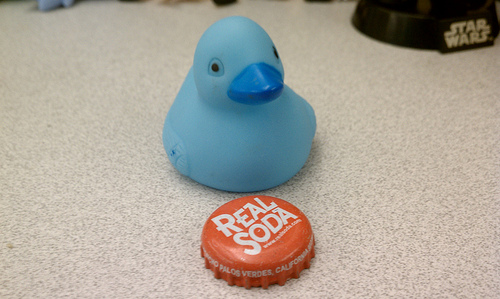<image>
Can you confirm if the label is on the bottle cap? Yes. Looking at the image, I can see the label is positioned on top of the bottle cap, with the bottle cap providing support. Is there a duck behind the soda cap? Yes. From this viewpoint, the duck is positioned behind the soda cap, with the soda cap partially or fully occluding the duck. Where is the blue duck in relation to the can cover? Is it behind the can cover? Yes. From this viewpoint, the blue duck is positioned behind the can cover, with the can cover partially or fully occluding the blue duck. 